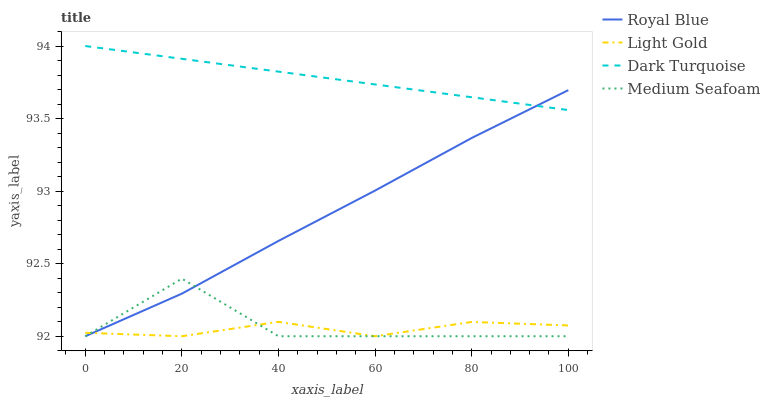Does Light Gold have the minimum area under the curve?
Answer yes or no. Yes. Does Dark Turquoise have the maximum area under the curve?
Answer yes or no. Yes. Does Medium Seafoam have the minimum area under the curve?
Answer yes or no. No. Does Medium Seafoam have the maximum area under the curve?
Answer yes or no. No. Is Dark Turquoise the smoothest?
Answer yes or no. Yes. Is Medium Seafoam the roughest?
Answer yes or no. Yes. Is Light Gold the smoothest?
Answer yes or no. No. Is Light Gold the roughest?
Answer yes or no. No. Does Royal Blue have the lowest value?
Answer yes or no. Yes. Does Dark Turquoise have the lowest value?
Answer yes or no. No. Does Dark Turquoise have the highest value?
Answer yes or no. Yes. Does Medium Seafoam have the highest value?
Answer yes or no. No. Is Light Gold less than Dark Turquoise?
Answer yes or no. Yes. Is Dark Turquoise greater than Light Gold?
Answer yes or no. Yes. Does Medium Seafoam intersect Royal Blue?
Answer yes or no. Yes. Is Medium Seafoam less than Royal Blue?
Answer yes or no. No. Is Medium Seafoam greater than Royal Blue?
Answer yes or no. No. Does Light Gold intersect Dark Turquoise?
Answer yes or no. No. 